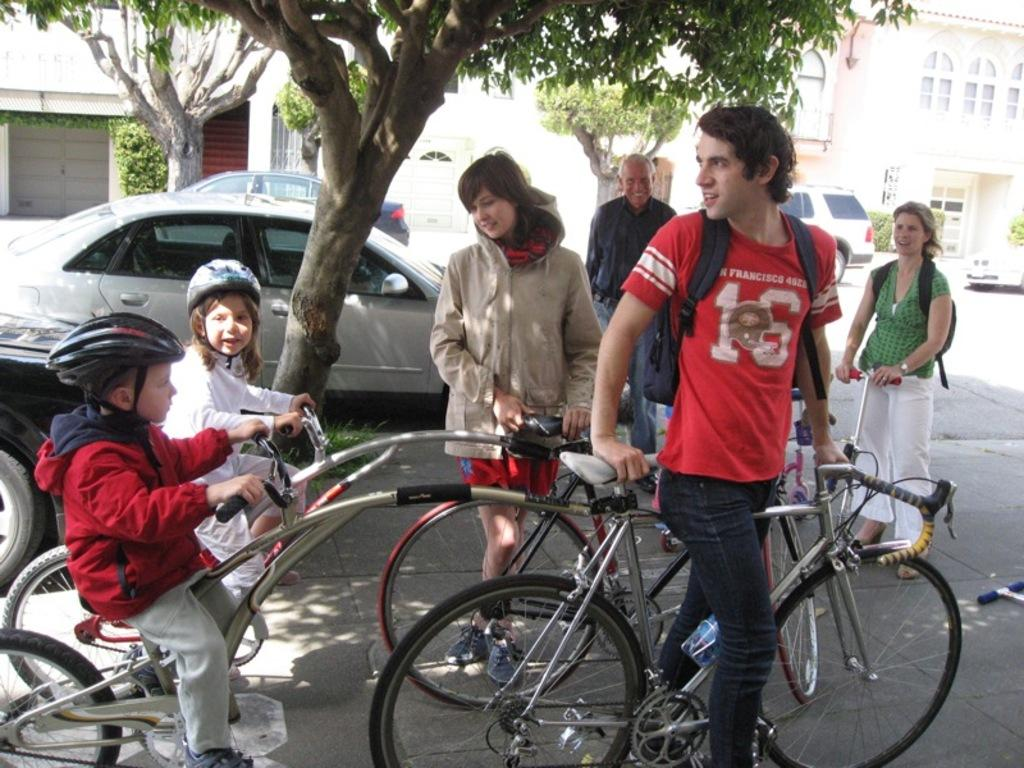How many people are present in the image? There are 6 people in the image. What are the positions of the people in the image? Two of the people are sitting, and the rest of the people are standing. What can be seen in the background of the image? There are cars, a path, trees, and buildings visible in the background. What type of bat can be seen flying in the image? There is no bat present in the image. What season might be suggested by the presence of snow in the image? There is no snow present in the image, so it cannot be determined if the season is winter. 